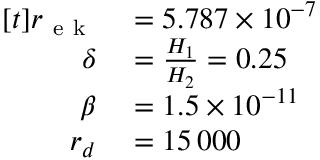<formula> <loc_0><loc_0><loc_500><loc_500>\begin{array} { r l } { [ t ] r _ { e k } } & = 5 . 7 8 7 \times 1 0 ^ { - 7 } } \\ { \delta } & = \frac { H _ { 1 } } { H _ { 2 } } = 0 . 2 5 } \\ { \beta } & = 1 . 5 \times 1 0 ^ { - 1 1 } } \\ { r _ { d } } & = 1 5 \, 0 0 0 } \end{array}</formula> 